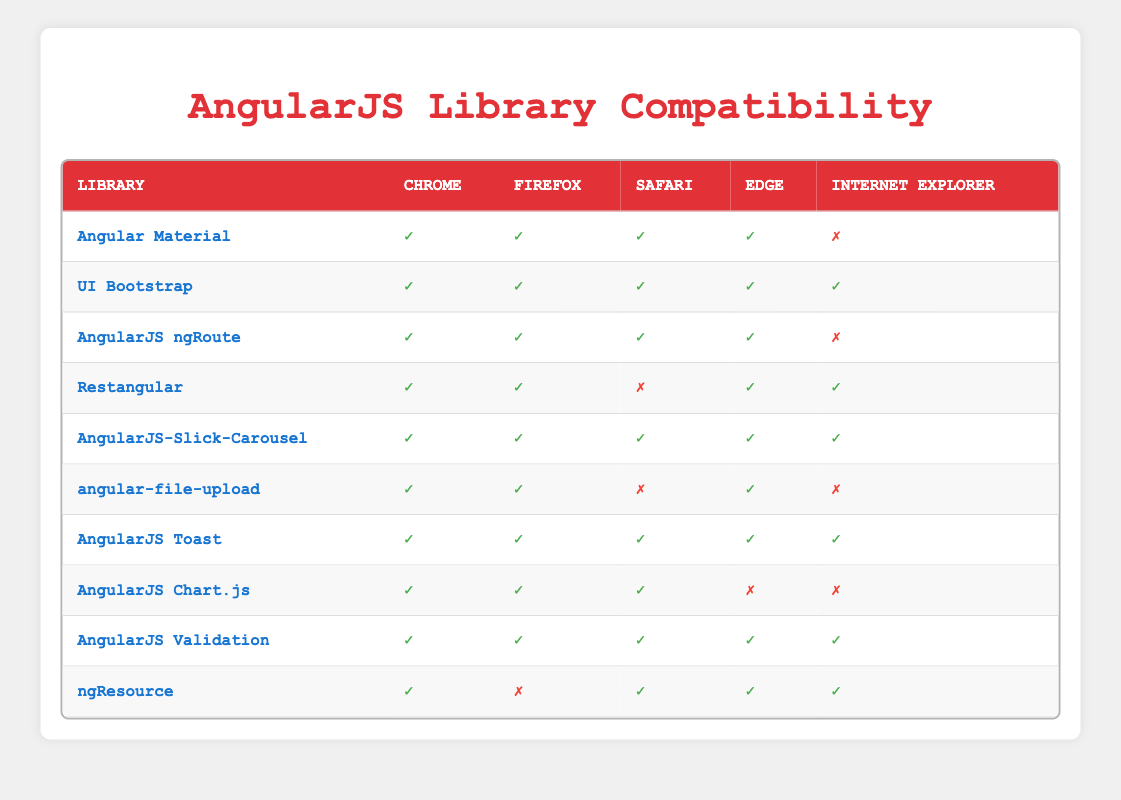What libraries are compatible with Internet Explorer? To find the libraries compatible with Internet Explorer, look for the rows where the Internet Explorer column has a '✓' (true) value. The libraries that have this indicator are: UI Bootstrap, Restangular, AngularJS-Slick-Carousel, AngularJS Toast, AngularJS Validation, and ngResource.
Answer: UI Bootstrap, Restangular, AngularJS-Slick-Carousel, AngularJS Toast, AngularJS Validation, ngResource Which library has the highest number of supported browsers? Reviewing the table, the library with '✓' (true) in all browsers (Chrome, Firefox, Safari, Edge, and Internet Explorer) is UI Bootstrap, AngularJS-Slick-Carousel, AngularJS Toast, and AngularJS Validation. That makes a total of 5 supported browsers. Other libraries do not reach this count.
Answer: UI Bootstrap, AngularJS-Slick-Carousel, AngularJS Toast, AngularJS Validation Is AngularJS ngRoute compatible with Firefox? Check the row corresponding to AngularJS ngRoute and look at the Firefox column. It has a '✓' (true) indicator, confirming that it is indeed compatible with Firefox.
Answer: Yes How many libraries support Safari? To find the number of libraries that support Safari, count the rows where the Safari column indicates '✓' (true). The libraries that meet this criterion are: Angular Material, UI Bootstrap, AngularJS ngRoute, AngularJS-Slick-Carousel, AngularJS Toast, AngularJS Chart.js, and ngResource, totaling 7 libraries.
Answer: 7 Are all libraries compatible with Chrome? By looking at the table, all libraries have a '✓' (true) in the Chrome column. Hence, every listed library is compatible with Chrome.
Answer: Yes What is the only library that supports Safari and does not support Internet Explorer? Refer to the columns for Safari and Internet Explorer, looking for a row with '✓' for Safari and '✗' for Internet Explorer. The library that meets this condition is Restangular.
Answer: Restangular Which library supports all browsers except Safari? Here, look for a library with '✓' in the Chrome, Firefox, Edge, and Internet Explorer columns but '✗' in the Safari column. That matches with angular-file-upload and AngularJS Chart.js, both of which fit this condition.
Answer: angular-file-upload, AngularJS Chart.js How many libraries are compatible with Edge? Count the libraries that have '✓' (true) under the Edge column. All libraries except AngularJS Chart.js and AngularJS ngRoute are compatible, giving a total of 8 compatible libraries with Edge.
Answer: 8 What is the difference in the number of libraries supporting Chrome and Firefox? Count the libraries that support Chrome (all 10) and those that support Firefox (8). The difference is 10 - 8 = 2, meaning 2 fewer libraries support Firefox than Chrome.
Answer: 2 